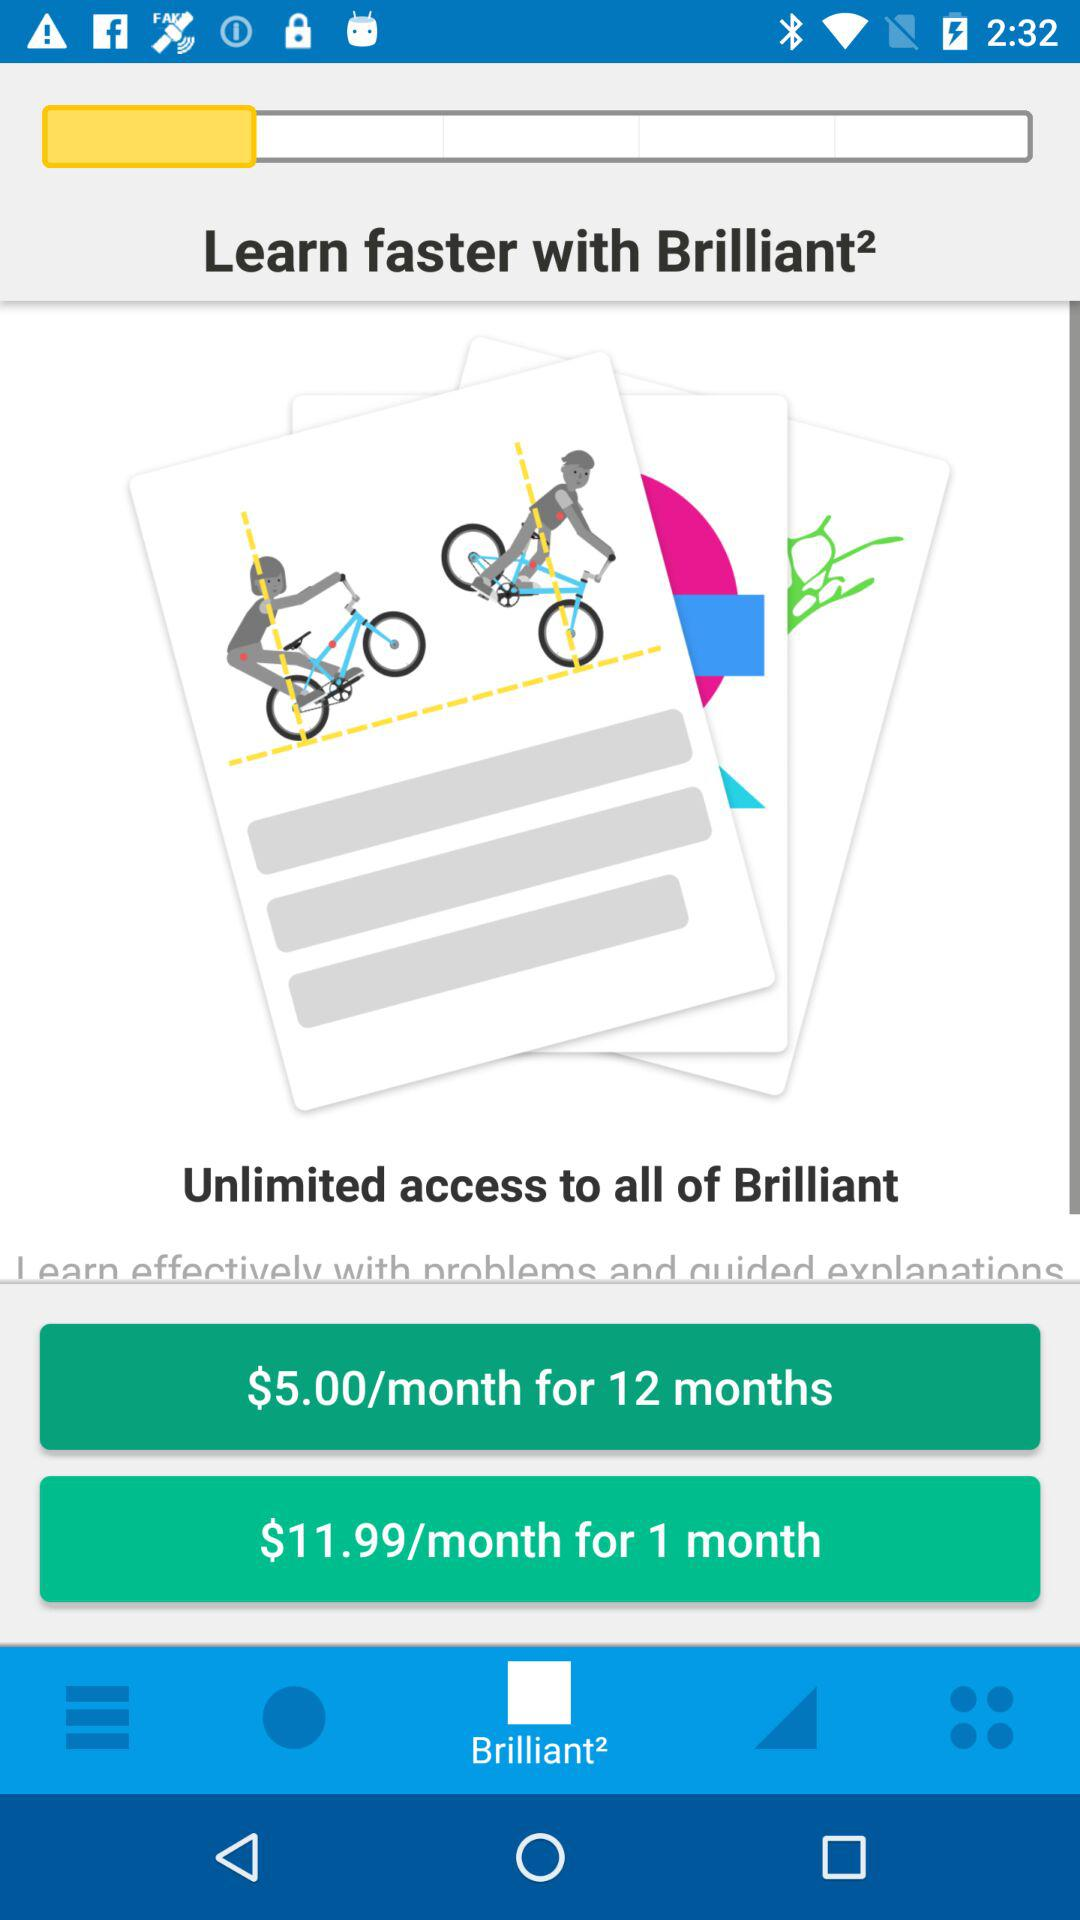What is the application name? The application name is "Brilliant²". 